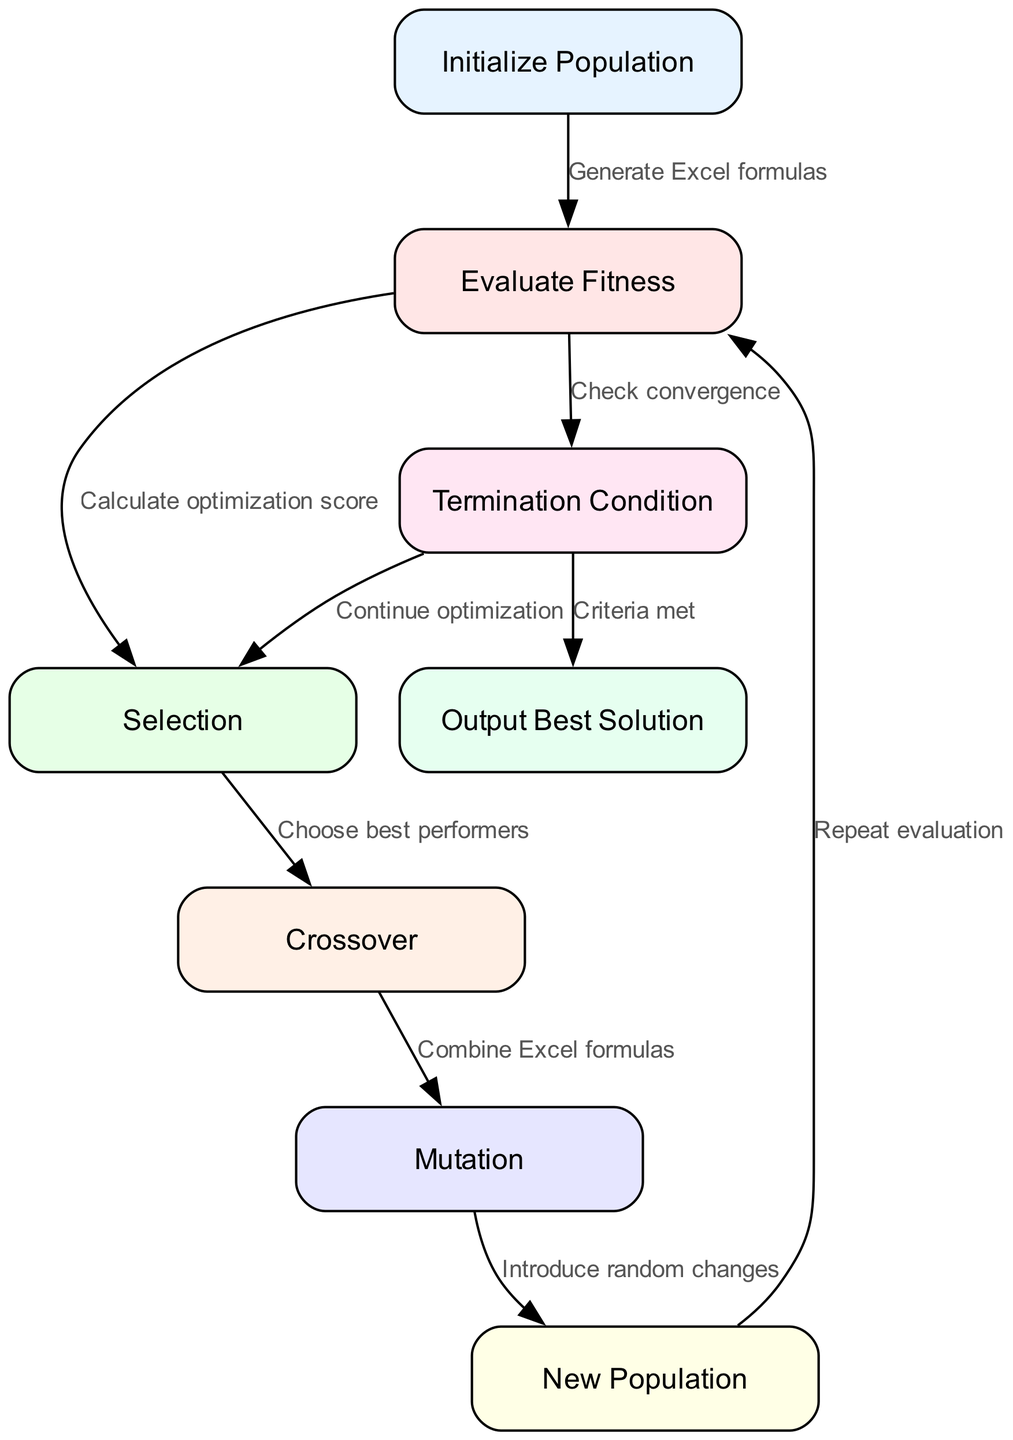What is the first step in the genetic algorithm? The first step in the diagram is labeled "Initialize Population". This indicates that the process starts with creating the initial group of candidate solutions.
Answer: Initialize Population How many nodes are present in the diagram? The diagram contains a total of eight nodes, each representing a distinct step in the genetic algorithm process.
Answer: 8 What is the output of the genetic algorithm? The output step is labeled "Output Best Solution", indicating that the final result of the genetic algorithm process is the best solution found.
Answer: Output Best Solution Which node follows the "Mutation" step? According to the diagram, the node that follows "Mutation" is labeled "New Population". This shows the progression from introducing random changes to forming new candidates.
Answer: New Population What is the termination condition based on? The termination condition is based on checking for convergence, ensuring that the algorithm is progressing toward a stable solution.
Answer: Check convergence If the termination condition is not met, which step is repeated? If the termination condition is not satisfied, the flowchart indicates that the process goes back to the "Selection" step, allowing for continued improvement of the solutions.
Answer: Selection What is the relationship between "Evaluate Fitness" and "Selection"? The relationship is defined by the edge labeled "Calculate optimization score", which links "Evaluate Fitness" to "Selection", signifying that fitness evaluation is necessary for selecting the best candidates.
Answer: Calculate optimization score What do the edges represent in this diagram? The edges in this diagram symbolize the relationships and flow of operations between different steps of the genetic algorithm process.
Answer: Relationships and operations flow 